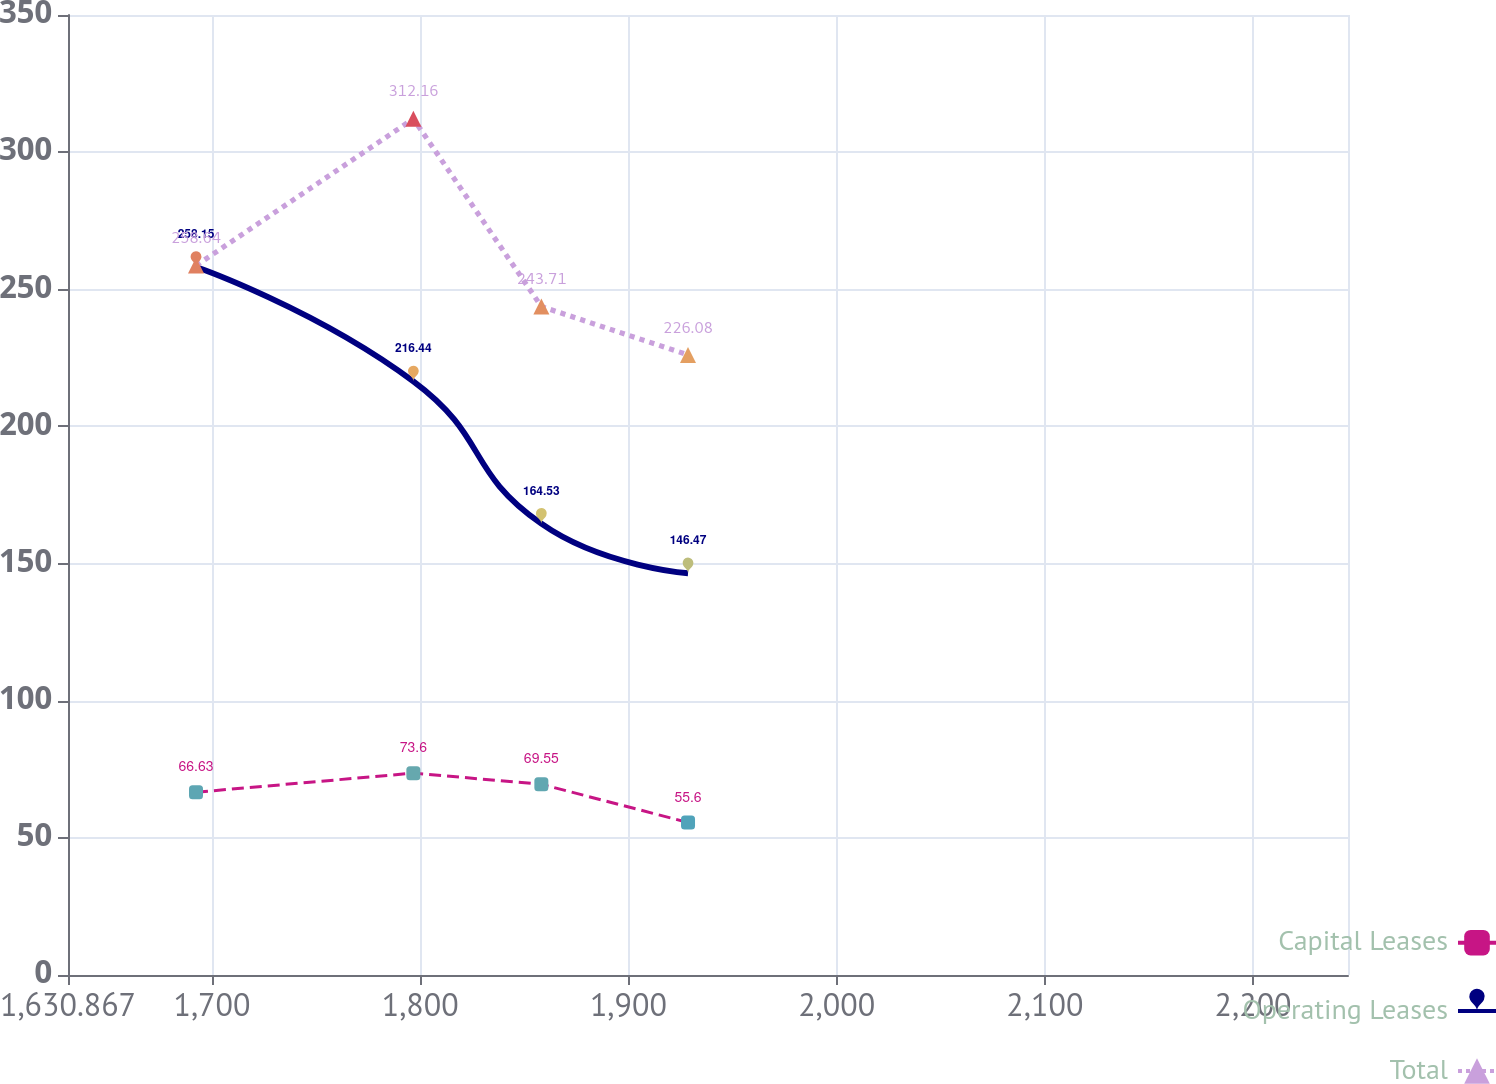<chart> <loc_0><loc_0><loc_500><loc_500><line_chart><ecel><fcel>Capital Leases<fcel>Operating Leases<fcel>Total<nl><fcel>1692.34<fcel>66.63<fcel>258.15<fcel>258.64<nl><fcel>1796.73<fcel>73.6<fcel>216.44<fcel>312.16<nl><fcel>1858.2<fcel>69.55<fcel>164.53<fcel>243.71<nl><fcel>1928.64<fcel>55.6<fcel>146.47<fcel>226.08<nl><fcel>2307.07<fcel>81.39<fcel>77.59<fcel>178.94<nl></chart> 